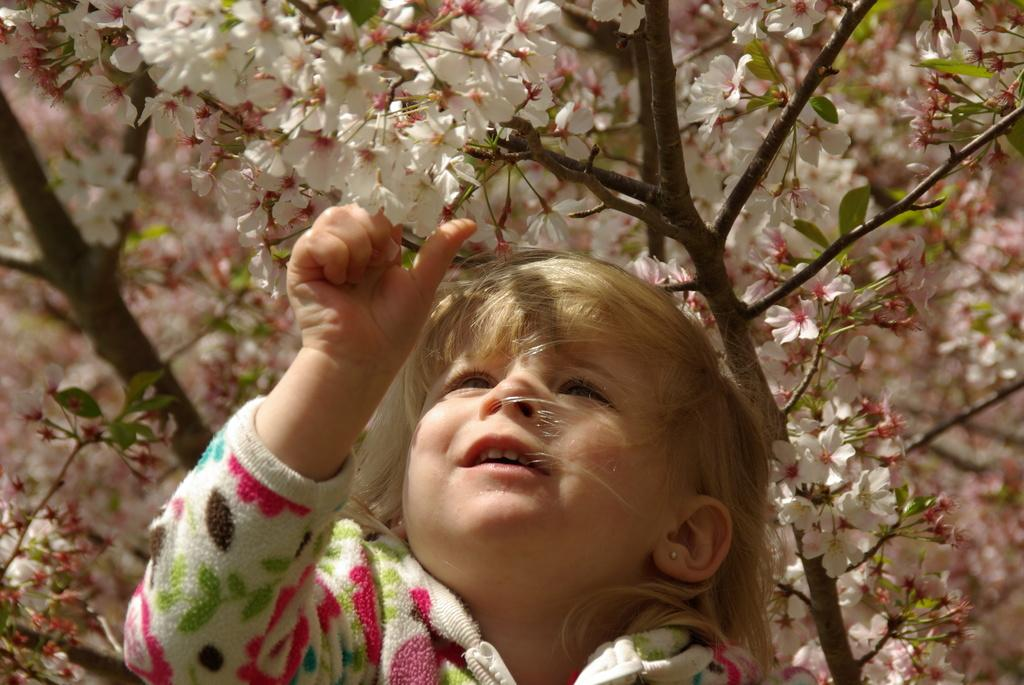Who is the main subject in the image? There is a girl in the image. What is the girl doing in the image? The girl is trying to pluck flowers. Where are the flowers located in relation to the girl? The flowers are in front of the girl. What can be seen in the background of the image? There is a flower plant in the background of the image. What is the girl's profit from plucking the flowers in the image? There is no mention of profit in the image, as it is focused on the girl's actions and the flowers. 